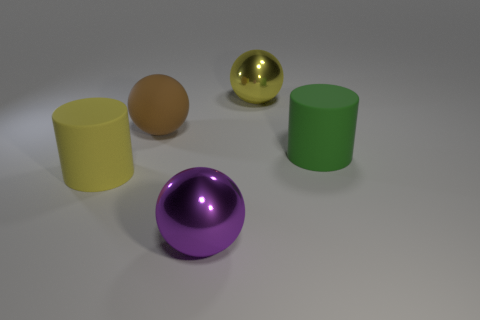Subtract all gray spheres. Subtract all purple cylinders. How many spheres are left? 3 Subtract all purple balls. How many brown cylinders are left? 0 Add 4 tiny browns. How many yellows exist? 0 Subtract all big purple balls. Subtract all green rubber cylinders. How many objects are left? 3 Add 4 big cylinders. How many big cylinders are left? 6 Add 2 large yellow rubber things. How many large yellow rubber things exist? 3 Add 5 metal things. How many objects exist? 10 Subtract all purple balls. How many balls are left? 2 Subtract all big purple shiny spheres. How many spheres are left? 2 Subtract 0 brown cylinders. How many objects are left? 5 